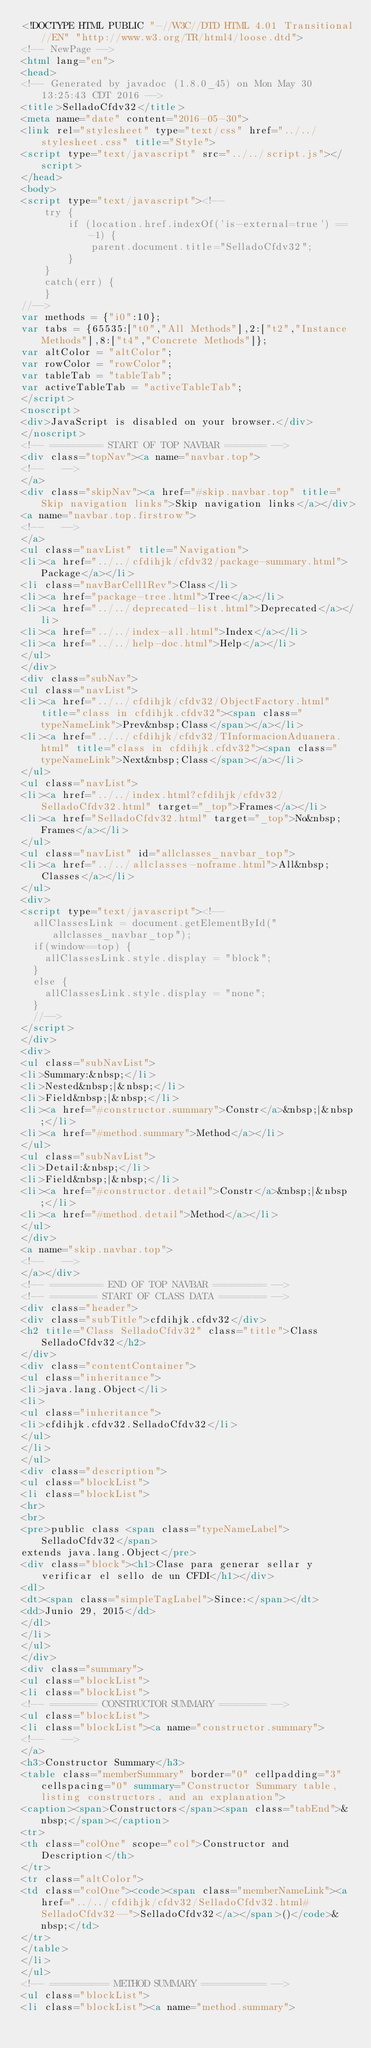<code> <loc_0><loc_0><loc_500><loc_500><_HTML_><!DOCTYPE HTML PUBLIC "-//W3C//DTD HTML 4.01 Transitional//EN" "http://www.w3.org/TR/html4/loose.dtd">
<!-- NewPage -->
<html lang="en">
<head>
<!-- Generated by javadoc (1.8.0_45) on Mon May 30 13:25:43 CDT 2016 -->
<title>SelladoCfdv32</title>
<meta name="date" content="2016-05-30">
<link rel="stylesheet" type="text/css" href="../../stylesheet.css" title="Style">
<script type="text/javascript" src="../../script.js"></script>
</head>
<body>
<script type="text/javascript"><!--
    try {
        if (location.href.indexOf('is-external=true') == -1) {
            parent.document.title="SelladoCfdv32";
        }
    }
    catch(err) {
    }
//-->
var methods = {"i0":10};
var tabs = {65535:["t0","All Methods"],2:["t2","Instance Methods"],8:["t4","Concrete Methods"]};
var altColor = "altColor";
var rowColor = "rowColor";
var tableTab = "tableTab";
var activeTableTab = "activeTableTab";
</script>
<noscript>
<div>JavaScript is disabled on your browser.</div>
</noscript>
<!-- ========= START OF TOP NAVBAR ======= -->
<div class="topNav"><a name="navbar.top">
<!--   -->
</a>
<div class="skipNav"><a href="#skip.navbar.top" title="Skip navigation links">Skip navigation links</a></div>
<a name="navbar.top.firstrow">
<!--   -->
</a>
<ul class="navList" title="Navigation">
<li><a href="../../cfdihjk/cfdv32/package-summary.html">Package</a></li>
<li class="navBarCell1Rev">Class</li>
<li><a href="package-tree.html">Tree</a></li>
<li><a href="../../deprecated-list.html">Deprecated</a></li>
<li><a href="../../index-all.html">Index</a></li>
<li><a href="../../help-doc.html">Help</a></li>
</ul>
</div>
<div class="subNav">
<ul class="navList">
<li><a href="../../cfdihjk/cfdv32/ObjectFactory.html" title="class in cfdihjk.cfdv32"><span class="typeNameLink">Prev&nbsp;Class</span></a></li>
<li><a href="../../cfdihjk/cfdv32/TInformacionAduanera.html" title="class in cfdihjk.cfdv32"><span class="typeNameLink">Next&nbsp;Class</span></a></li>
</ul>
<ul class="navList">
<li><a href="../../index.html?cfdihjk/cfdv32/SelladoCfdv32.html" target="_top">Frames</a></li>
<li><a href="SelladoCfdv32.html" target="_top">No&nbsp;Frames</a></li>
</ul>
<ul class="navList" id="allclasses_navbar_top">
<li><a href="../../allclasses-noframe.html">All&nbsp;Classes</a></li>
</ul>
<div>
<script type="text/javascript"><!--
  allClassesLink = document.getElementById("allclasses_navbar_top");
  if(window==top) {
    allClassesLink.style.display = "block";
  }
  else {
    allClassesLink.style.display = "none";
  }
  //-->
</script>
</div>
<div>
<ul class="subNavList">
<li>Summary:&nbsp;</li>
<li>Nested&nbsp;|&nbsp;</li>
<li>Field&nbsp;|&nbsp;</li>
<li><a href="#constructor.summary">Constr</a>&nbsp;|&nbsp;</li>
<li><a href="#method.summary">Method</a></li>
</ul>
<ul class="subNavList">
<li>Detail:&nbsp;</li>
<li>Field&nbsp;|&nbsp;</li>
<li><a href="#constructor.detail">Constr</a>&nbsp;|&nbsp;</li>
<li><a href="#method.detail">Method</a></li>
</ul>
</div>
<a name="skip.navbar.top">
<!--   -->
</a></div>
<!-- ========= END OF TOP NAVBAR ========= -->
<!-- ======== START OF CLASS DATA ======== -->
<div class="header">
<div class="subTitle">cfdihjk.cfdv32</div>
<h2 title="Class SelladoCfdv32" class="title">Class SelladoCfdv32</h2>
</div>
<div class="contentContainer">
<ul class="inheritance">
<li>java.lang.Object</li>
<li>
<ul class="inheritance">
<li>cfdihjk.cfdv32.SelladoCfdv32</li>
</ul>
</li>
</ul>
<div class="description">
<ul class="blockList">
<li class="blockList">
<hr>
<br>
<pre>public class <span class="typeNameLabel">SelladoCfdv32</span>
extends java.lang.Object</pre>
<div class="block"><h1>Clase para generar sellar y verificar el sello de un CFDI</h1></div>
<dl>
<dt><span class="simpleTagLabel">Since:</span></dt>
<dd>Junio 29, 2015</dd>
</dl>
</li>
</ul>
</div>
<div class="summary">
<ul class="blockList">
<li class="blockList">
<!-- ======== CONSTRUCTOR SUMMARY ======== -->
<ul class="blockList">
<li class="blockList"><a name="constructor.summary">
<!--   -->
</a>
<h3>Constructor Summary</h3>
<table class="memberSummary" border="0" cellpadding="3" cellspacing="0" summary="Constructor Summary table, listing constructors, and an explanation">
<caption><span>Constructors</span><span class="tabEnd">&nbsp;</span></caption>
<tr>
<th class="colOne" scope="col">Constructor and Description</th>
</tr>
<tr class="altColor">
<td class="colOne"><code><span class="memberNameLink"><a href="../../cfdihjk/cfdv32/SelladoCfdv32.html#SelladoCfdv32--">SelladoCfdv32</a></span>()</code>&nbsp;</td>
</tr>
</table>
</li>
</ul>
<!-- ========== METHOD SUMMARY =========== -->
<ul class="blockList">
<li class="blockList"><a name="method.summary"></code> 